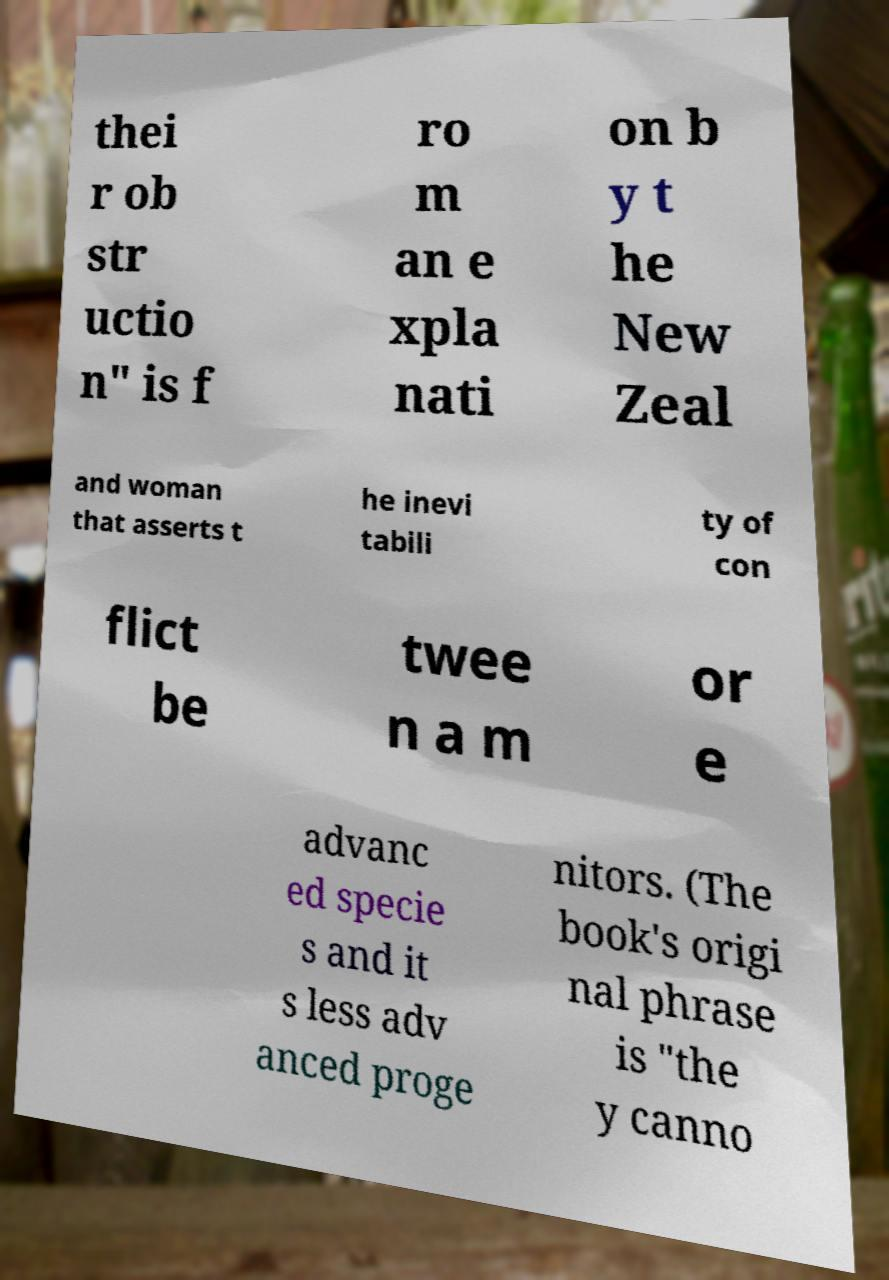Could you extract and type out the text from this image? thei r ob str uctio n" is f ro m an e xpla nati on b y t he New Zeal and woman that asserts t he inevi tabili ty of con flict be twee n a m or e advanc ed specie s and it s less adv anced proge nitors. (The book's origi nal phrase is "the y canno 